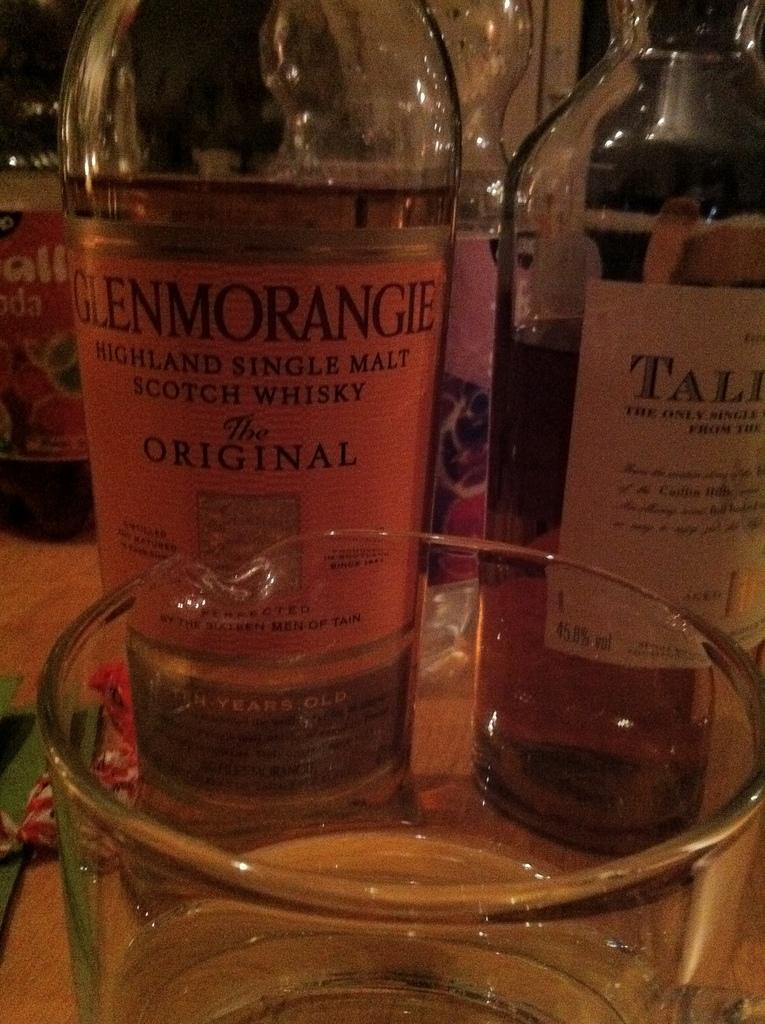<image>
Give a short and clear explanation of the subsequent image. A bottle of Scotch Whiskey is on a table next to other bottles. 